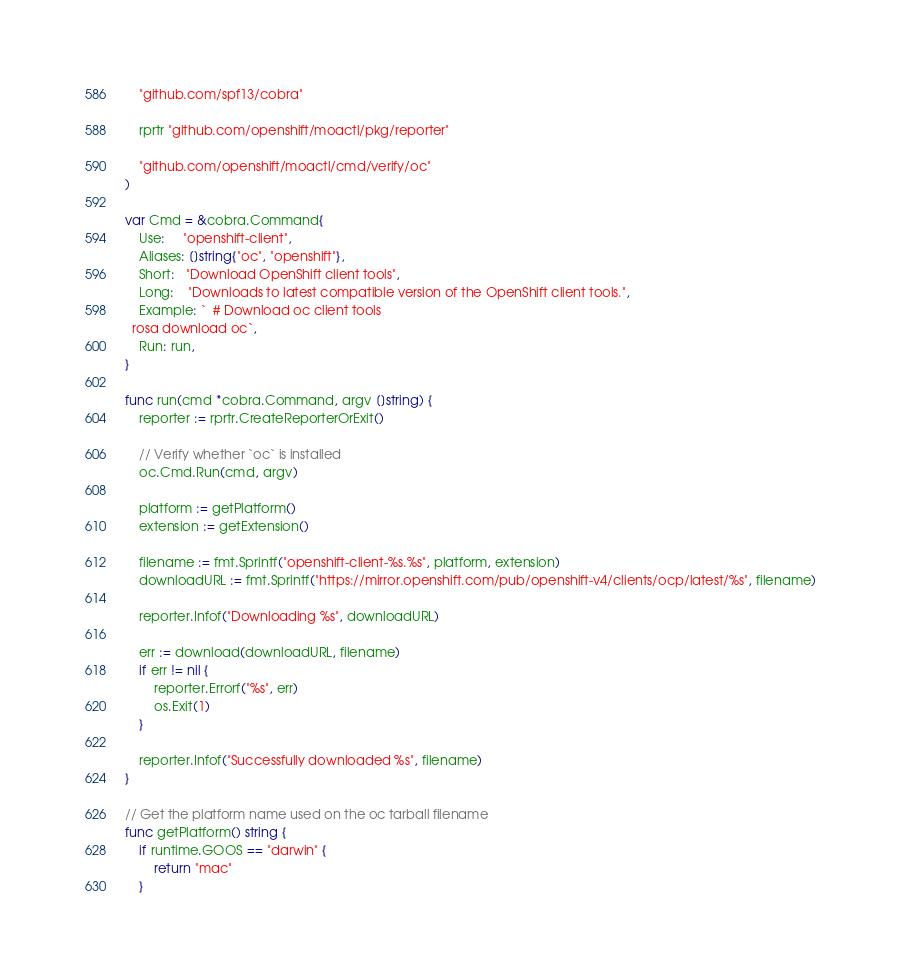<code> <loc_0><loc_0><loc_500><loc_500><_Go_>	"github.com/spf13/cobra"

	rprtr "github.com/openshift/moactl/pkg/reporter"

	"github.com/openshift/moactl/cmd/verify/oc"
)

var Cmd = &cobra.Command{
	Use:     "openshift-client",
	Aliases: []string{"oc", "openshift"},
	Short:   "Download OpenShift client tools",
	Long:    "Downloads to latest compatible version of the OpenShift client tools.",
	Example: `  # Download oc client tools
  rosa download oc`,
	Run: run,
}

func run(cmd *cobra.Command, argv []string) {
	reporter := rprtr.CreateReporterOrExit()

	// Verify whether `oc` is installed
	oc.Cmd.Run(cmd, argv)

	platform := getPlatform()
	extension := getExtension()

	filename := fmt.Sprintf("openshift-client-%s.%s", platform, extension)
	downloadURL := fmt.Sprintf("https://mirror.openshift.com/pub/openshift-v4/clients/ocp/latest/%s", filename)

	reporter.Infof("Downloading %s", downloadURL)

	err := download(downloadURL, filename)
	if err != nil {
		reporter.Errorf("%s", err)
		os.Exit(1)
	}

	reporter.Infof("Successfully downloaded %s", filename)
}

// Get the platform name used on the oc tarball filename
func getPlatform() string {
	if runtime.GOOS == "darwin" {
		return "mac"
	}</code> 